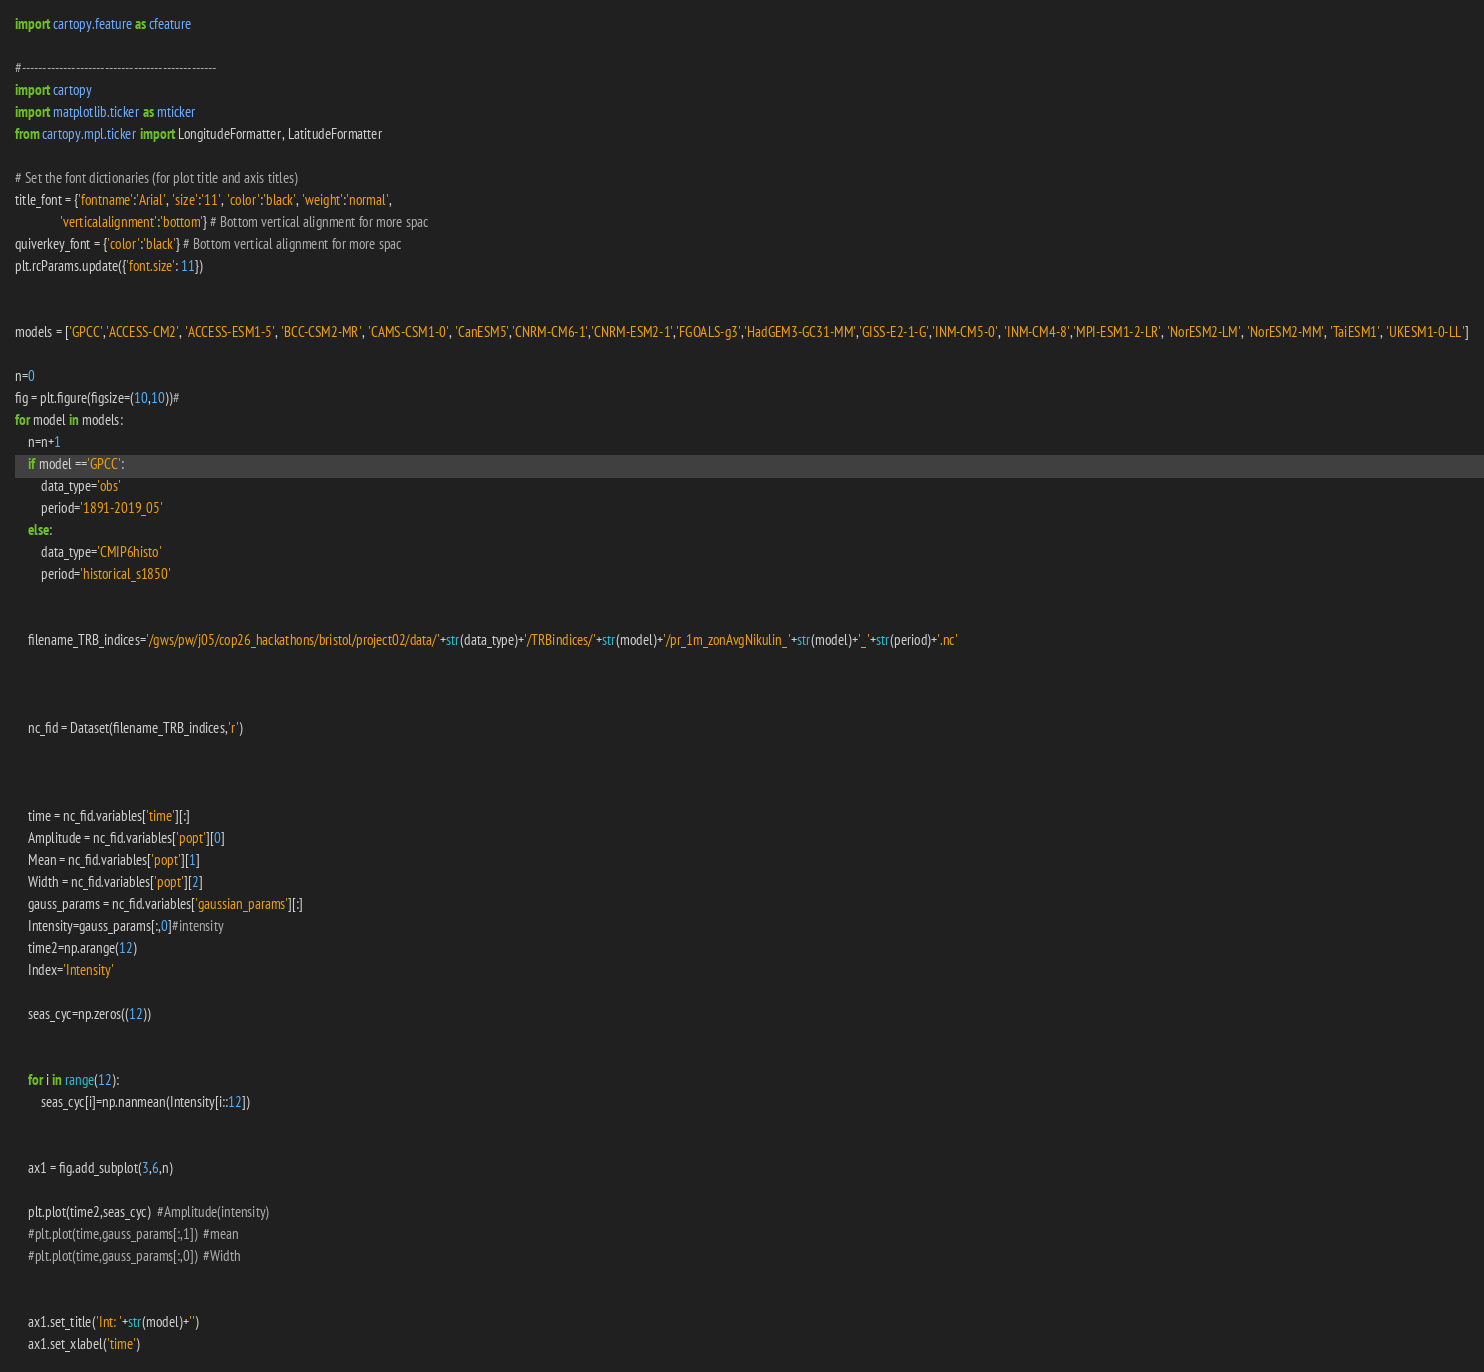Convert code to text. <code><loc_0><loc_0><loc_500><loc_500><_Python_>import cartopy.feature as cfeature

#-----------------------------------------------
import cartopy
import matplotlib.ticker as mticker
from cartopy.mpl.ticker import LongitudeFormatter, LatitudeFormatter

# Set the font dictionaries (for plot title and axis titles)
title_font = {'fontname':'Arial', 'size':'11', 'color':'black', 'weight':'normal',
              'verticalalignment':'bottom'} # Bottom vertical alignment for more spac
quiverkey_font = {'color':'black'} # Bottom vertical alignment for more spac
plt.rcParams.update({'font.size': 11})


models = ['GPCC','ACCESS-CM2', 'ACCESS-ESM1-5', 'BCC-CSM2-MR', 'CAMS-CSM1-0', 'CanESM5','CNRM-CM6-1','CNRM-ESM2-1','FGOALS-g3','HadGEM3-GC31-MM','GISS-E2-1-G','INM-CM5-0', 'INM-CM4-8','MPI-ESM1-2-LR', 'NorESM2-LM', 'NorESM2-MM', 'TaiESM1', 'UKESM1-0-LL']

n=0
fig = plt.figure(figsize=(10,10))#
for model in models:
	n=n+1
	if model =='GPCC':
		data_type='obs'
		period='1891-2019_05'
	else:
		data_type='CMIP6histo'
		period='historical_s1850'
	

	filename_TRB_indices='/gws/pw/j05/cop26_hackathons/bristol/project02/data/'+str(data_type)+'/TRBindices/'+str(model)+'/pr_1m_zonAvgNikulin_'+str(model)+'_'+str(period)+'.nc'

	

	nc_fid = Dataset(filename_TRB_indices,'r')



	time = nc_fid.variables['time'][:]
	Amplitude = nc_fid.variables['popt'][0]
	Mean = nc_fid.variables['popt'][1]
	Width = nc_fid.variables['popt'][2]
	gauss_params = nc_fid.variables['gaussian_params'][:]
	Intensity=gauss_params[:,0]#intensity
	time2=np.arange(12)
	Index='Intensity'
	
	seas_cyc=np.zeros((12))
	
	
	for i in range(12):
		seas_cyc[i]=np.nanmean(Intensity[i::12])

	
	ax1 = fig.add_subplot(3,6,n)

	plt.plot(time2,seas_cyc)  #Amplitude(intensity)
	#plt.plot(time,gauss_params[:,1])  #mean
	#plt.plot(time,gauss_params[:,0])  #Width


	ax1.set_title('Int: '+str(model)+'')
	ax1.set_xlabel('time')



</code> 